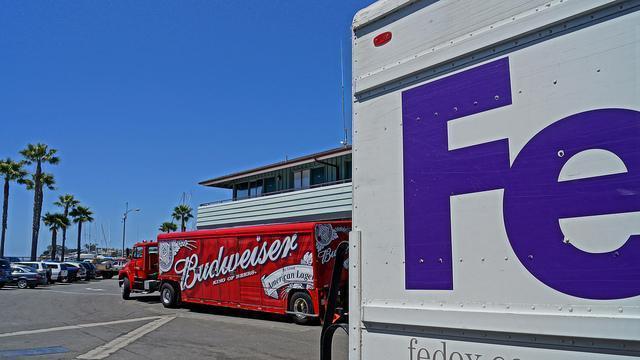How many trucks are there?
Give a very brief answer. 2. How many people have the same color coat?
Give a very brief answer. 0. 